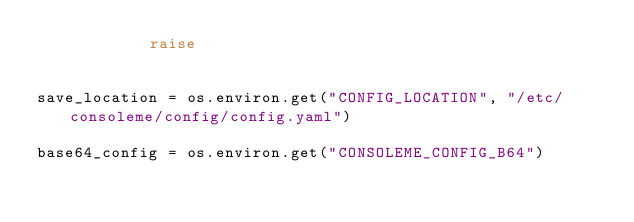Convert code to text. <code><loc_0><loc_0><loc_500><loc_500><_Python_>            raise


save_location = os.environ.get("CONFIG_LOCATION", "/etc/consoleme/config/config.yaml")

base64_config = os.environ.get("CONSOLEME_CONFIG_B64")</code> 